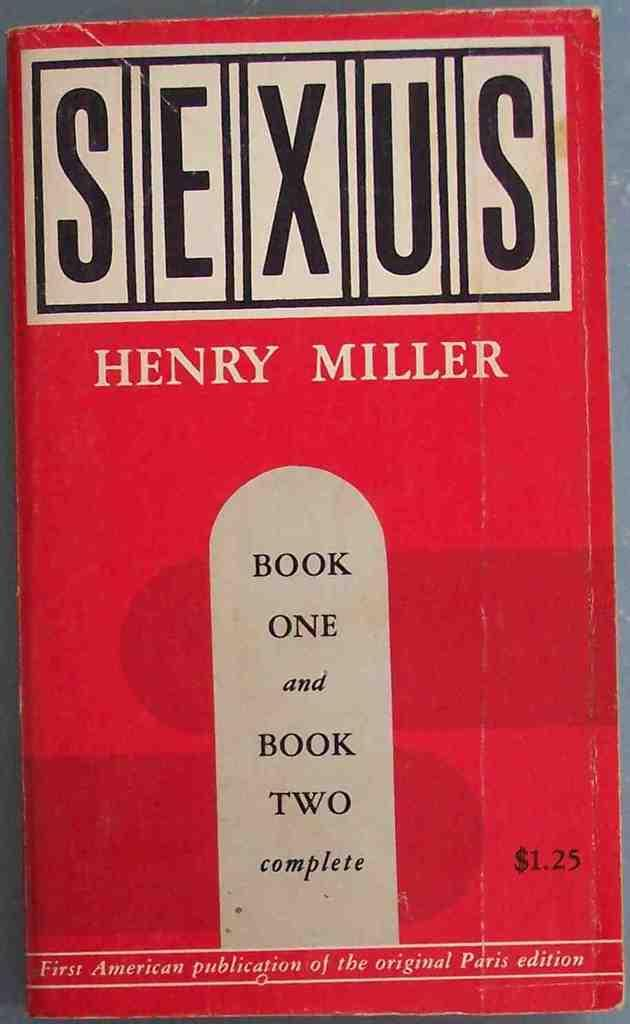<image>
Describe the image concisely. Book One and Book Two complete of Henry Miller's Sexus 